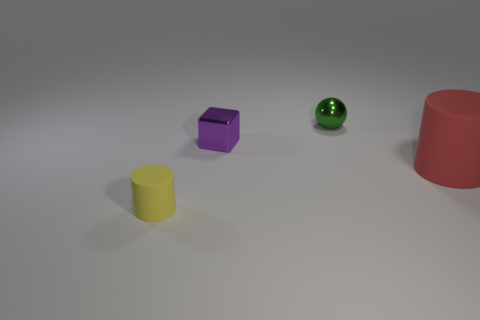Is the number of rubber cylinders that are left of the shiny block greater than the number of big green rubber cylinders?
Your answer should be very brief. Yes. The tiny object that is in front of the rubber cylinder that is on the right side of the cylinder in front of the red cylinder is what color?
Offer a very short reply. Yellow. Is the material of the tiny purple block the same as the red cylinder?
Your response must be concise. No. Is there a shiny sphere of the same size as the purple object?
Keep it short and to the point. Yes. What is the material of the purple block that is the same size as the green metal thing?
Keep it short and to the point. Metal. Is there a large red thing of the same shape as the tiny matte object?
Offer a terse response. Yes. The thing that is in front of the big red object has what shape?
Ensure brevity in your answer.  Cylinder. What number of yellow objects are there?
Ensure brevity in your answer.  1. There is another cylinder that is the same material as the tiny cylinder; what color is it?
Offer a very short reply. Red. How many large objects are either cubes or spheres?
Your response must be concise. 0. 